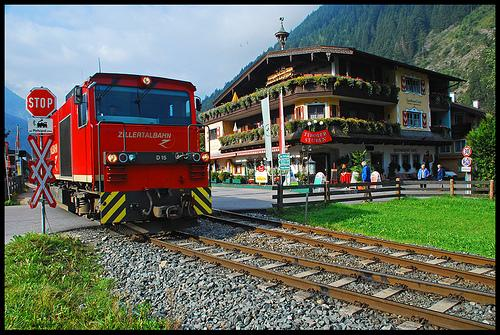What zone is this area?

Choices:
A) tourist
B) residential
C) shopping
D) business tourist 